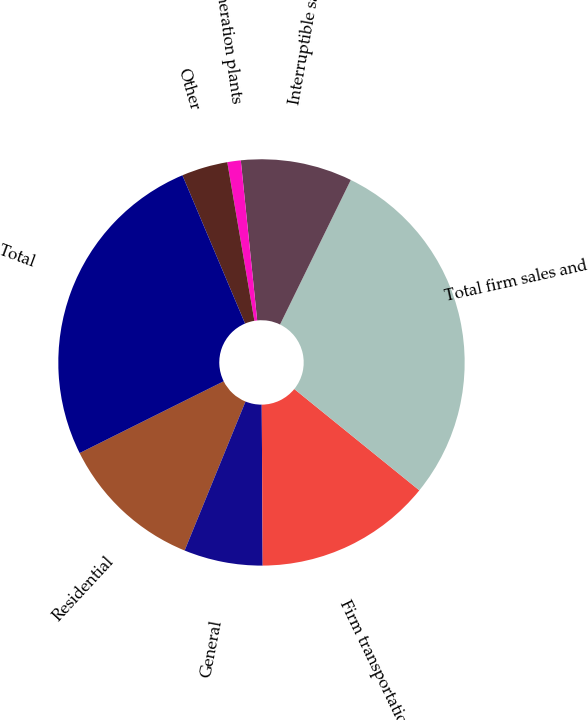<chart> <loc_0><loc_0><loc_500><loc_500><pie_chart><fcel>Residential<fcel>General<fcel>Firm transportation<fcel>Total firm sales and<fcel>Interruptible sales<fcel>Generation plants<fcel>Other<fcel>Total<nl><fcel>11.47%<fcel>6.27%<fcel>14.07%<fcel>28.6%<fcel>8.87%<fcel>1.07%<fcel>3.67%<fcel>26.0%<nl></chart> 